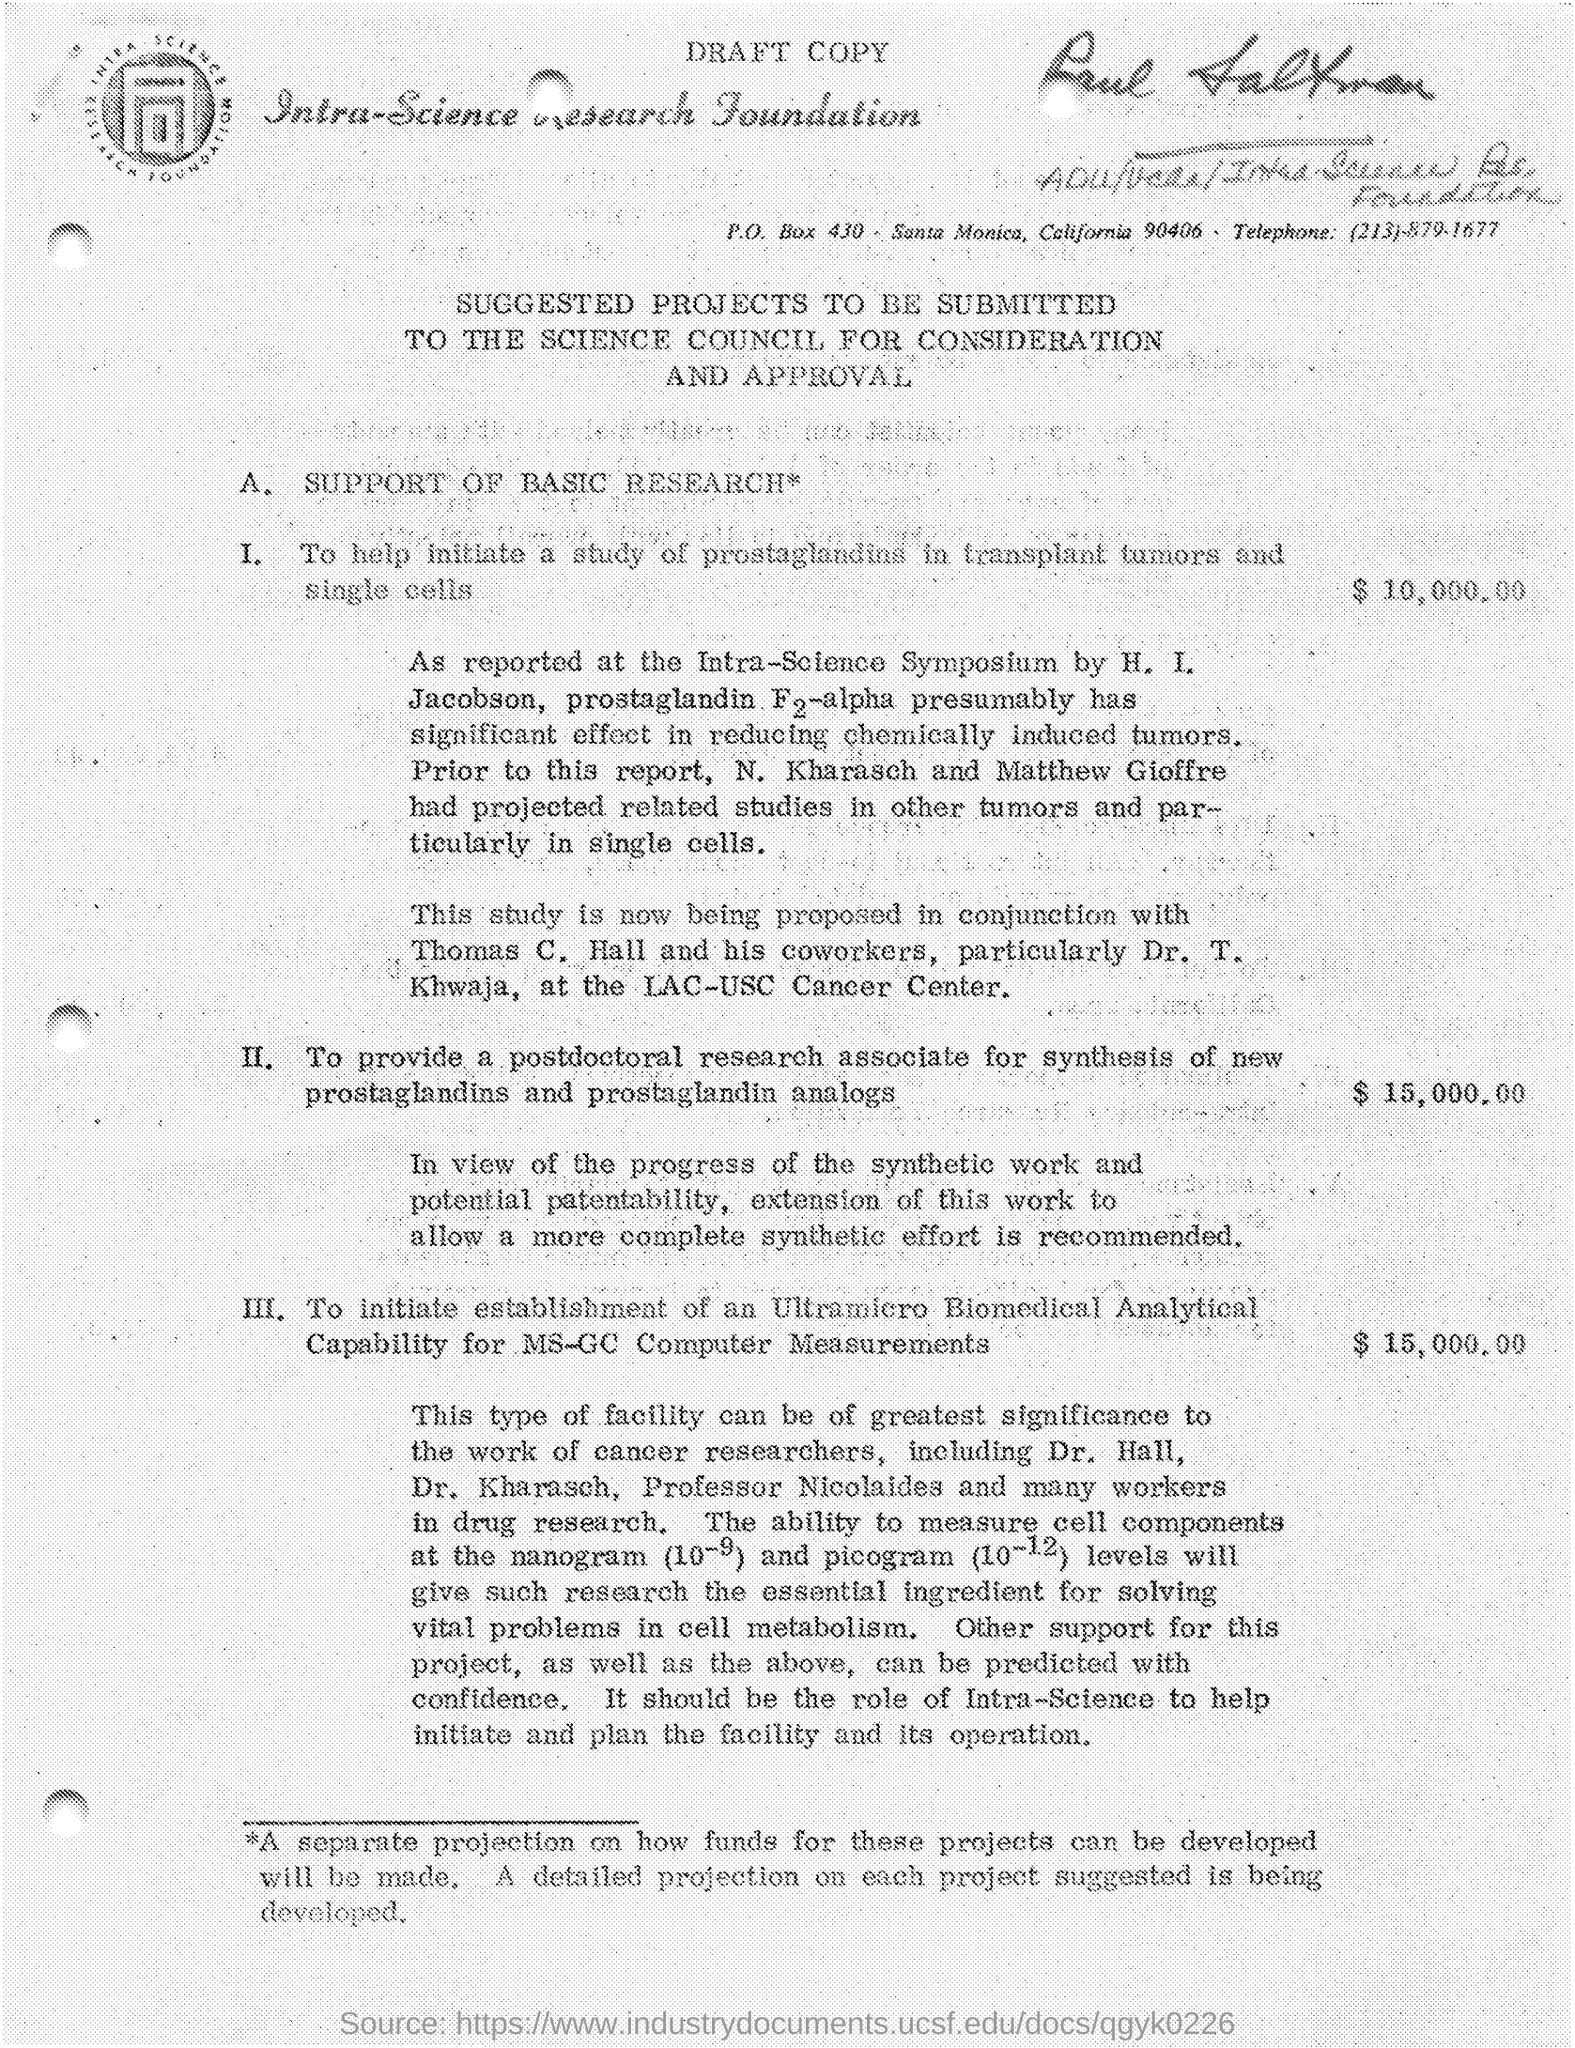What is the PO Box Number mentioned in the document?
Offer a very short reply. 430. What is the telephone number?
Give a very brief answer. (213)-879-1677. 